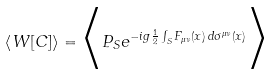Convert formula to latex. <formula><loc_0><loc_0><loc_500><loc_500>\left \langle W [ C ] \right \rangle = \Big < P _ { S } e ^ { - i g \frac { 1 } { 2 } \int _ { S } F _ { \mu \nu } ( x ) \, d \sigma ^ { \mu \nu } ( x ) } \Big ></formula> 